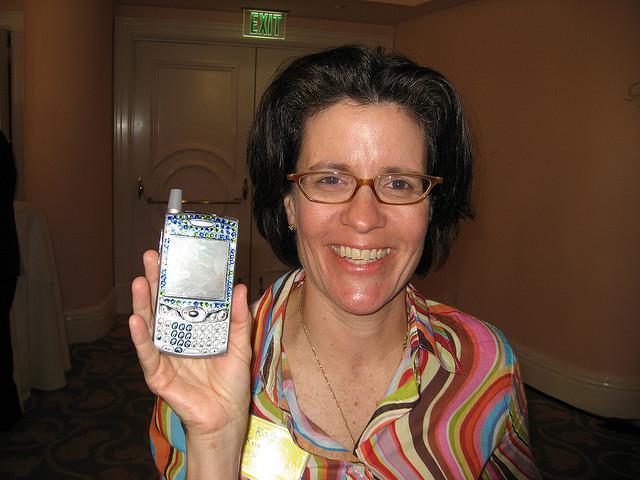How many cell phones does he have?
Give a very brief answer. 1. 